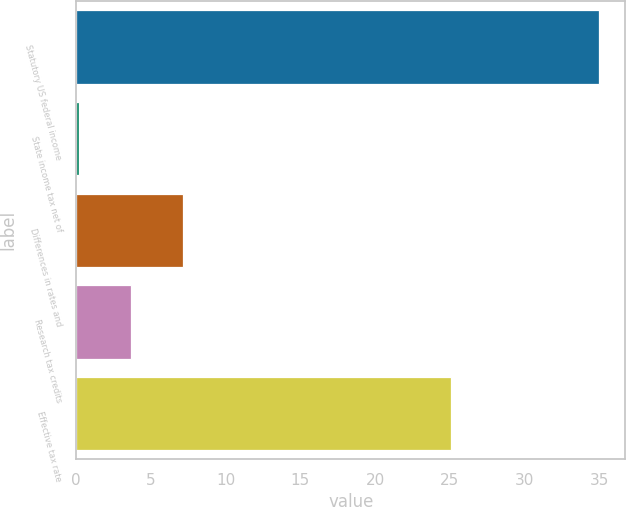<chart> <loc_0><loc_0><loc_500><loc_500><bar_chart><fcel>Statutory US federal income<fcel>State income tax net of<fcel>Differences in rates and<fcel>Research tax credits<fcel>Effective tax rate<nl><fcel>35<fcel>0.2<fcel>7.18<fcel>3.7<fcel>25.1<nl></chart> 